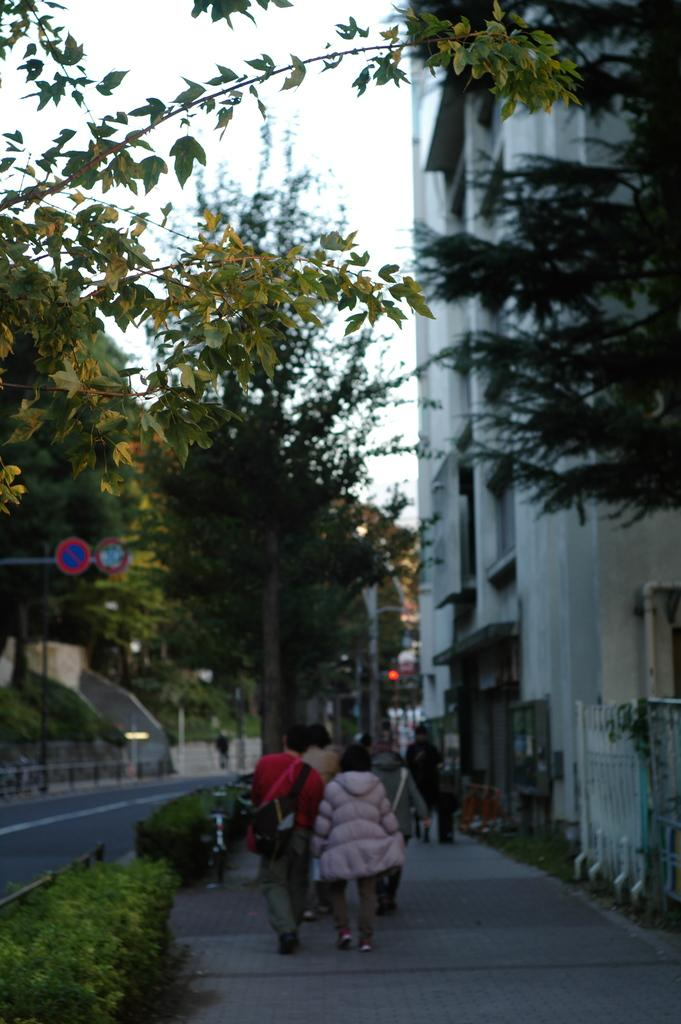What are the people in the image doing? The people in the image are walking on the side of the road. What type of natural elements can be seen in the image? Trees and plants are visible in the image. What type of man-made structures are present in the image? Buildings are present in the image. What song is being sung by the trees in the image? There is no indication in the image that the trees are singing a song. 